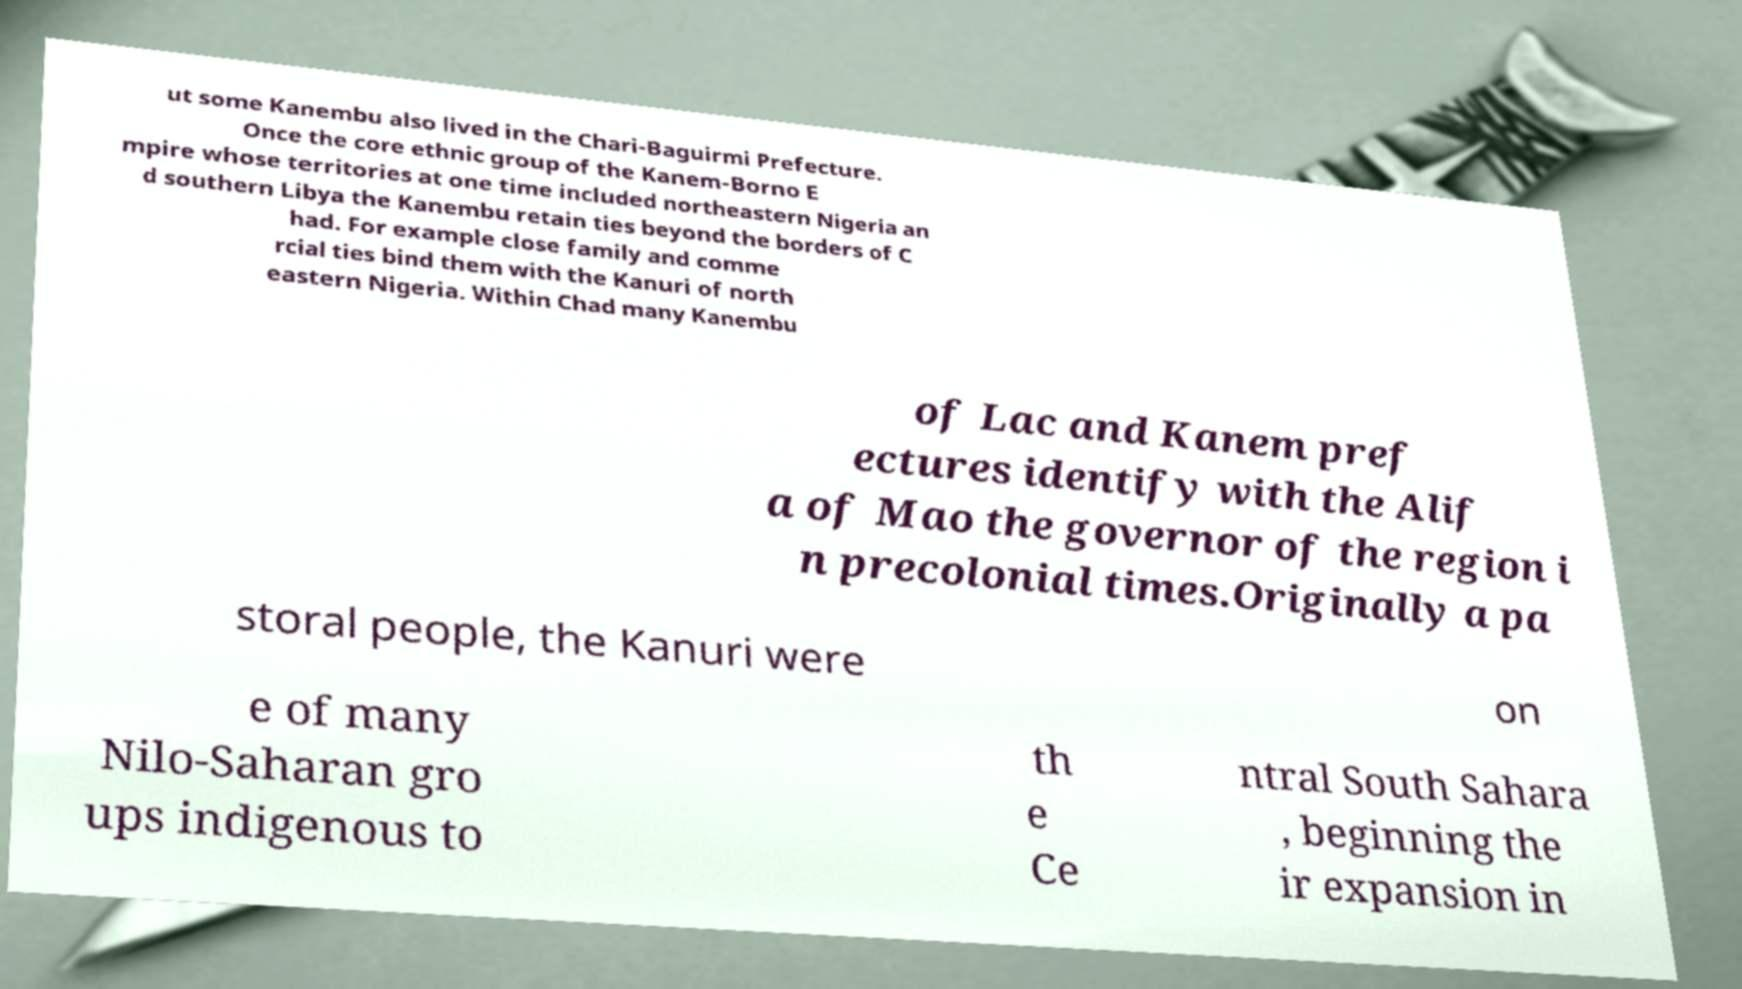Could you extract and type out the text from this image? ut some Kanembu also lived in the Chari-Baguirmi Prefecture. Once the core ethnic group of the Kanem-Borno E mpire whose territories at one time included northeastern Nigeria an d southern Libya the Kanembu retain ties beyond the borders of C had. For example close family and comme rcial ties bind them with the Kanuri of north eastern Nigeria. Within Chad many Kanembu of Lac and Kanem pref ectures identify with the Alif a of Mao the governor of the region i n precolonial times.Originally a pa storal people, the Kanuri were on e of many Nilo-Saharan gro ups indigenous to th e Ce ntral South Sahara , beginning the ir expansion in 